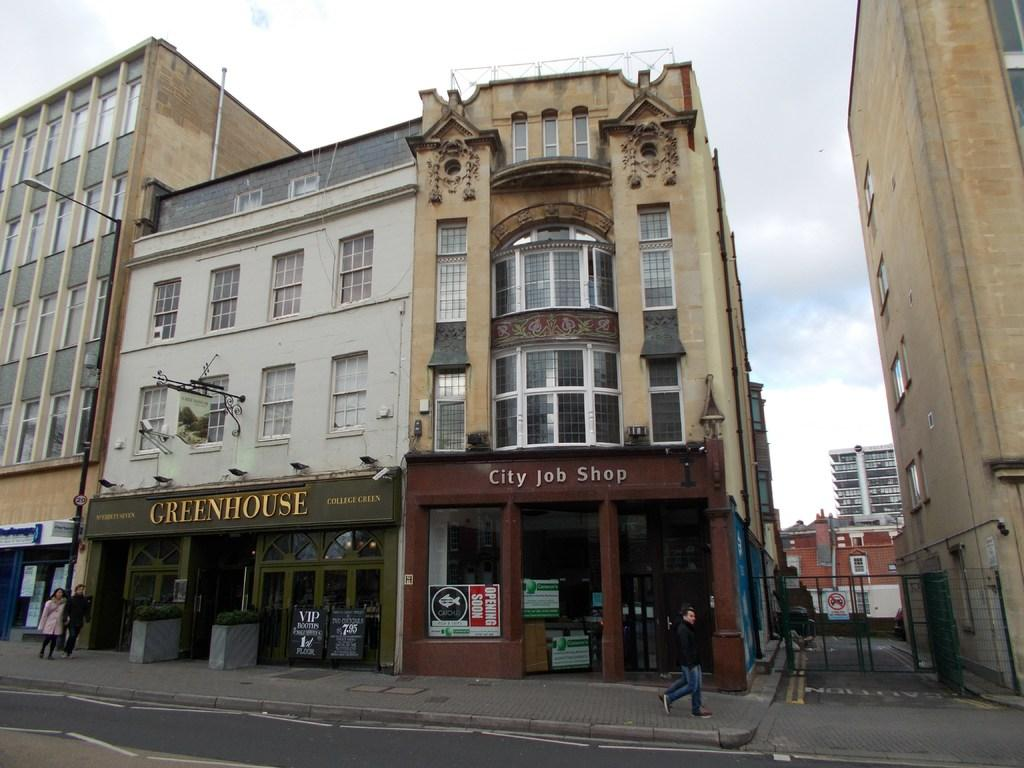What are the people in the image doing? The people in the image are walking. What objects can be seen in the image that are made of wood or a similar material? There are boards visible in the image. What type of vegetation is present in the image? There are plants in the image. What type of structures can be seen in the image? There are buildings in the image. What is on the glass surface in the image? There is a poster on a glass surface in the image. What type of pathway is visible in the image? There is a road in the image. What part of the natural environment is visible in the image? The sky is visible in the image. What type of zinc object can be seen in the image? There is no zinc object present in the image. Can you see anyone in the image using a rifle? There is no rifle present in the image. 